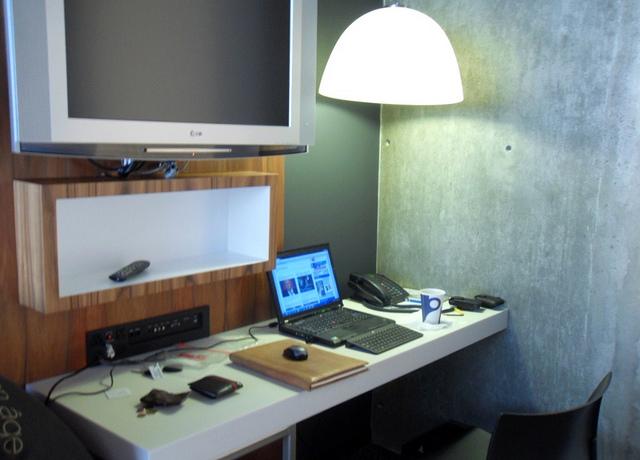Is the computer on?
Give a very brief answer. Yes. Is there a notebook on the desk?
Give a very brief answer. Yes. Is the tv on?
Write a very short answer. No. 